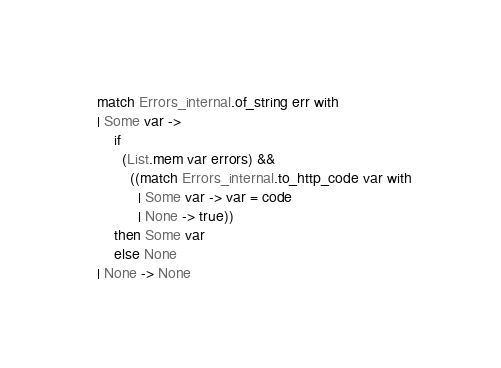<code> <loc_0><loc_0><loc_500><loc_500><_OCaml_>  match Errors_internal.of_string err with
  | Some var ->
      if
        (List.mem var errors) &&
          ((match Errors_internal.to_http_code var with
            | Some var -> var = code
            | None -> true))
      then Some var
      else None
  | None -> None</code> 